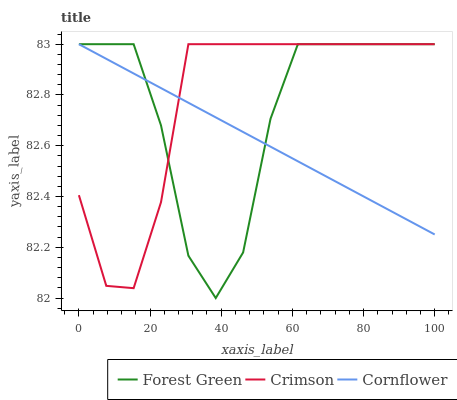Does Forest Green have the minimum area under the curve?
Answer yes or no. No. Does Forest Green have the maximum area under the curve?
Answer yes or no. No. Is Forest Green the smoothest?
Answer yes or no. No. Is Cornflower the roughest?
Answer yes or no. No. Does Cornflower have the lowest value?
Answer yes or no. No. 